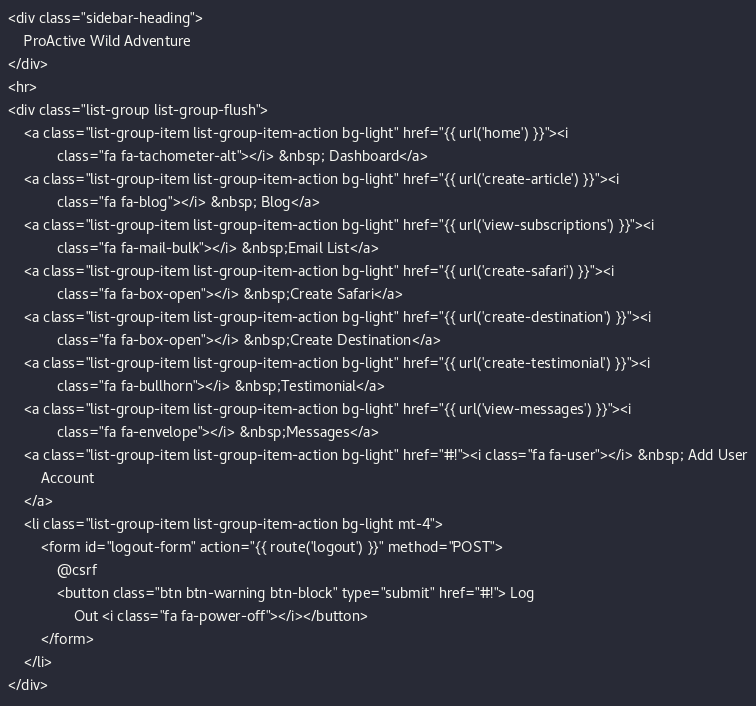<code> <loc_0><loc_0><loc_500><loc_500><_PHP_><div class="sidebar-heading">
    ProActive Wild Adventure
</div>
<hr>
<div class="list-group list-group-flush">
    <a class="list-group-item list-group-item-action bg-light" href="{{ url('home') }}"><i
            class="fa fa-tachometer-alt"></i> &nbsp; Dashboard</a>
    <a class="list-group-item list-group-item-action bg-light" href="{{ url('create-article') }}"><i
            class="fa fa-blog"></i> &nbsp; Blog</a>
    <a class="list-group-item list-group-item-action bg-light" href="{{ url('view-subscriptions') }}"><i
            class="fa fa-mail-bulk"></i> &nbsp;Email List</a>
    <a class="list-group-item list-group-item-action bg-light" href="{{ url('create-safari') }}"><i
            class="fa fa-box-open"></i> &nbsp;Create Safari</a>
    <a class="list-group-item list-group-item-action bg-light" href="{{ url('create-destination') }}"><i
            class="fa fa-box-open"></i> &nbsp;Create Destination</a>
    <a class="list-group-item list-group-item-action bg-light" href="{{ url('create-testimonial') }}"><i
            class="fa fa-bullhorn"></i> &nbsp;Testimonial</a>
    <a class="list-group-item list-group-item-action bg-light" href="{{ url('view-messages') }}"><i
            class="fa fa-envelope"></i> &nbsp;Messages</a>
    <a class="list-group-item list-group-item-action bg-light" href="#!"><i class="fa fa-user"></i> &nbsp; Add User
        Account
    </a>
    <li class="list-group-item list-group-item-action bg-light mt-4">
        <form id="logout-form" action="{{ route('logout') }}" method="POST">
            @csrf
            <button class="btn btn-warning btn-block" type="submit" href="#!"> Log
                Out <i class="fa fa-power-off"></i></button>
        </form>
    </li>
</div>
</code> 